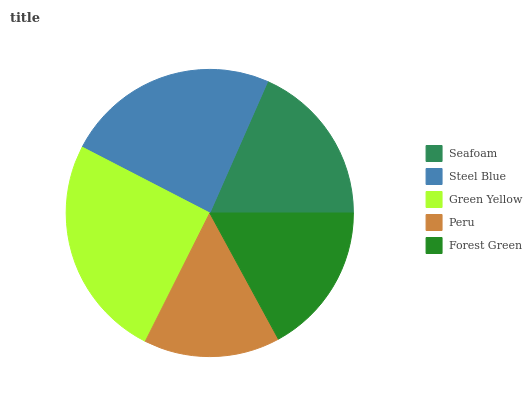Is Peru the minimum?
Answer yes or no. Yes. Is Green Yellow the maximum?
Answer yes or no. Yes. Is Steel Blue the minimum?
Answer yes or no. No. Is Steel Blue the maximum?
Answer yes or no. No. Is Steel Blue greater than Seafoam?
Answer yes or no. Yes. Is Seafoam less than Steel Blue?
Answer yes or no. Yes. Is Seafoam greater than Steel Blue?
Answer yes or no. No. Is Steel Blue less than Seafoam?
Answer yes or no. No. Is Seafoam the high median?
Answer yes or no. Yes. Is Seafoam the low median?
Answer yes or no. Yes. Is Peru the high median?
Answer yes or no. No. Is Steel Blue the low median?
Answer yes or no. No. 